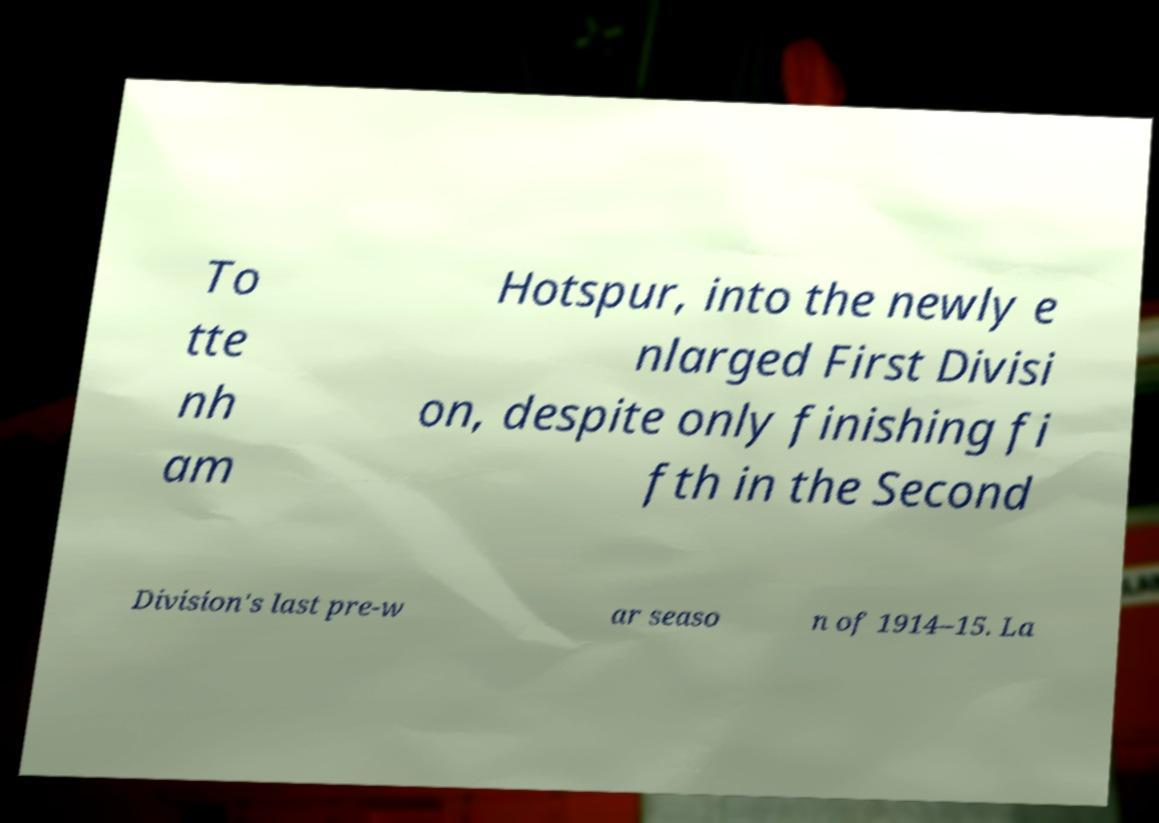Can you read and provide the text displayed in the image?This photo seems to have some interesting text. Can you extract and type it out for me? To tte nh am Hotspur, into the newly e nlarged First Divisi on, despite only finishing fi fth in the Second Division's last pre-w ar seaso n of 1914–15. La 